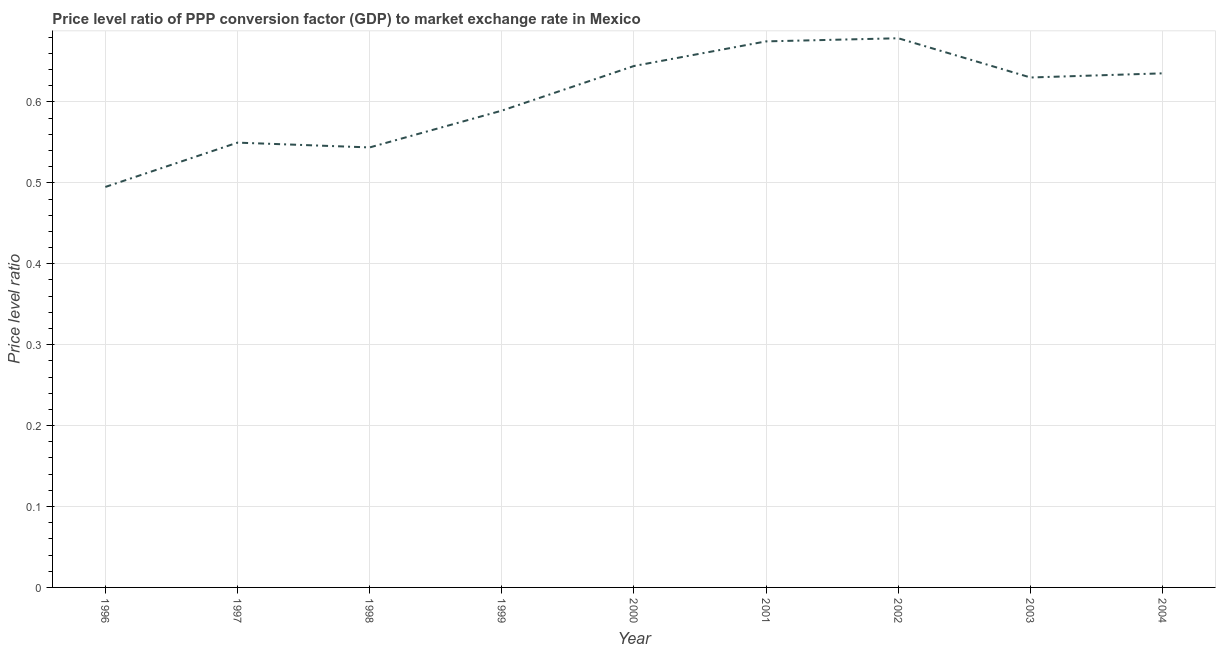What is the price level ratio in 1999?
Provide a succinct answer. 0.59. Across all years, what is the maximum price level ratio?
Offer a terse response. 0.68. Across all years, what is the minimum price level ratio?
Ensure brevity in your answer.  0.49. In which year was the price level ratio maximum?
Your answer should be very brief. 2002. In which year was the price level ratio minimum?
Keep it short and to the point. 1996. What is the sum of the price level ratio?
Your answer should be compact. 5.44. What is the difference between the price level ratio in 1998 and 2003?
Provide a short and direct response. -0.09. What is the average price level ratio per year?
Keep it short and to the point. 0.6. What is the median price level ratio?
Offer a terse response. 0.63. Do a majority of the years between 2001 and 2002 (inclusive) have price level ratio greater than 0.46 ?
Offer a very short reply. Yes. What is the ratio of the price level ratio in 2001 to that in 2003?
Your response must be concise. 1.07. What is the difference between the highest and the second highest price level ratio?
Provide a succinct answer. 0. What is the difference between the highest and the lowest price level ratio?
Your answer should be very brief. 0.18. How many lines are there?
Your response must be concise. 1. What is the difference between two consecutive major ticks on the Y-axis?
Offer a terse response. 0.1. Are the values on the major ticks of Y-axis written in scientific E-notation?
Ensure brevity in your answer.  No. Does the graph contain any zero values?
Make the answer very short. No. What is the title of the graph?
Provide a short and direct response. Price level ratio of PPP conversion factor (GDP) to market exchange rate in Mexico. What is the label or title of the X-axis?
Provide a succinct answer. Year. What is the label or title of the Y-axis?
Keep it short and to the point. Price level ratio. What is the Price level ratio in 1996?
Offer a terse response. 0.49. What is the Price level ratio in 1997?
Make the answer very short. 0.55. What is the Price level ratio in 1998?
Keep it short and to the point. 0.54. What is the Price level ratio of 1999?
Your response must be concise. 0.59. What is the Price level ratio of 2000?
Your answer should be very brief. 0.64. What is the Price level ratio of 2001?
Your response must be concise. 0.67. What is the Price level ratio in 2002?
Your answer should be very brief. 0.68. What is the Price level ratio in 2003?
Your answer should be compact. 0.63. What is the Price level ratio in 2004?
Your answer should be compact. 0.64. What is the difference between the Price level ratio in 1996 and 1997?
Your answer should be compact. -0.05. What is the difference between the Price level ratio in 1996 and 1998?
Make the answer very short. -0.05. What is the difference between the Price level ratio in 1996 and 1999?
Make the answer very short. -0.09. What is the difference between the Price level ratio in 1996 and 2000?
Give a very brief answer. -0.15. What is the difference between the Price level ratio in 1996 and 2001?
Ensure brevity in your answer.  -0.18. What is the difference between the Price level ratio in 1996 and 2002?
Keep it short and to the point. -0.18. What is the difference between the Price level ratio in 1996 and 2003?
Your answer should be very brief. -0.14. What is the difference between the Price level ratio in 1996 and 2004?
Make the answer very short. -0.14. What is the difference between the Price level ratio in 1997 and 1998?
Your response must be concise. 0.01. What is the difference between the Price level ratio in 1997 and 1999?
Give a very brief answer. -0.04. What is the difference between the Price level ratio in 1997 and 2000?
Your response must be concise. -0.09. What is the difference between the Price level ratio in 1997 and 2001?
Keep it short and to the point. -0.13. What is the difference between the Price level ratio in 1997 and 2002?
Offer a very short reply. -0.13. What is the difference between the Price level ratio in 1997 and 2003?
Provide a succinct answer. -0.08. What is the difference between the Price level ratio in 1997 and 2004?
Keep it short and to the point. -0.09. What is the difference between the Price level ratio in 1998 and 1999?
Your answer should be very brief. -0.05. What is the difference between the Price level ratio in 1998 and 2000?
Provide a short and direct response. -0.1. What is the difference between the Price level ratio in 1998 and 2001?
Your answer should be very brief. -0.13. What is the difference between the Price level ratio in 1998 and 2002?
Ensure brevity in your answer.  -0.13. What is the difference between the Price level ratio in 1998 and 2003?
Keep it short and to the point. -0.09. What is the difference between the Price level ratio in 1998 and 2004?
Offer a very short reply. -0.09. What is the difference between the Price level ratio in 1999 and 2000?
Provide a succinct answer. -0.06. What is the difference between the Price level ratio in 1999 and 2001?
Make the answer very short. -0.09. What is the difference between the Price level ratio in 1999 and 2002?
Give a very brief answer. -0.09. What is the difference between the Price level ratio in 1999 and 2003?
Provide a short and direct response. -0.04. What is the difference between the Price level ratio in 1999 and 2004?
Give a very brief answer. -0.05. What is the difference between the Price level ratio in 2000 and 2001?
Provide a succinct answer. -0.03. What is the difference between the Price level ratio in 2000 and 2002?
Ensure brevity in your answer.  -0.03. What is the difference between the Price level ratio in 2000 and 2003?
Give a very brief answer. 0.01. What is the difference between the Price level ratio in 2000 and 2004?
Give a very brief answer. 0.01. What is the difference between the Price level ratio in 2001 and 2002?
Your answer should be very brief. -0. What is the difference between the Price level ratio in 2001 and 2003?
Keep it short and to the point. 0.04. What is the difference between the Price level ratio in 2001 and 2004?
Your response must be concise. 0.04. What is the difference between the Price level ratio in 2002 and 2003?
Give a very brief answer. 0.05. What is the difference between the Price level ratio in 2002 and 2004?
Keep it short and to the point. 0.04. What is the difference between the Price level ratio in 2003 and 2004?
Your answer should be very brief. -0.01. What is the ratio of the Price level ratio in 1996 to that in 1998?
Make the answer very short. 0.91. What is the ratio of the Price level ratio in 1996 to that in 1999?
Provide a short and direct response. 0.84. What is the ratio of the Price level ratio in 1996 to that in 2000?
Give a very brief answer. 0.77. What is the ratio of the Price level ratio in 1996 to that in 2001?
Your answer should be compact. 0.73. What is the ratio of the Price level ratio in 1996 to that in 2002?
Ensure brevity in your answer.  0.73. What is the ratio of the Price level ratio in 1996 to that in 2003?
Your answer should be compact. 0.79. What is the ratio of the Price level ratio in 1996 to that in 2004?
Provide a succinct answer. 0.78. What is the ratio of the Price level ratio in 1997 to that in 1998?
Offer a terse response. 1.01. What is the ratio of the Price level ratio in 1997 to that in 1999?
Offer a terse response. 0.93. What is the ratio of the Price level ratio in 1997 to that in 2000?
Provide a short and direct response. 0.85. What is the ratio of the Price level ratio in 1997 to that in 2001?
Offer a terse response. 0.81. What is the ratio of the Price level ratio in 1997 to that in 2002?
Offer a very short reply. 0.81. What is the ratio of the Price level ratio in 1997 to that in 2003?
Make the answer very short. 0.87. What is the ratio of the Price level ratio in 1997 to that in 2004?
Give a very brief answer. 0.86. What is the ratio of the Price level ratio in 1998 to that in 1999?
Your answer should be very brief. 0.92. What is the ratio of the Price level ratio in 1998 to that in 2000?
Your response must be concise. 0.84. What is the ratio of the Price level ratio in 1998 to that in 2001?
Provide a succinct answer. 0.81. What is the ratio of the Price level ratio in 1998 to that in 2002?
Make the answer very short. 0.8. What is the ratio of the Price level ratio in 1998 to that in 2003?
Your response must be concise. 0.86. What is the ratio of the Price level ratio in 1998 to that in 2004?
Ensure brevity in your answer.  0.86. What is the ratio of the Price level ratio in 1999 to that in 2000?
Give a very brief answer. 0.91. What is the ratio of the Price level ratio in 1999 to that in 2001?
Your response must be concise. 0.87. What is the ratio of the Price level ratio in 1999 to that in 2002?
Your response must be concise. 0.87. What is the ratio of the Price level ratio in 1999 to that in 2003?
Provide a succinct answer. 0.94. What is the ratio of the Price level ratio in 1999 to that in 2004?
Give a very brief answer. 0.93. What is the ratio of the Price level ratio in 2000 to that in 2001?
Provide a short and direct response. 0.95. What is the ratio of the Price level ratio in 2000 to that in 2003?
Keep it short and to the point. 1.02. What is the ratio of the Price level ratio in 2001 to that in 2003?
Keep it short and to the point. 1.07. What is the ratio of the Price level ratio in 2001 to that in 2004?
Your answer should be very brief. 1.06. What is the ratio of the Price level ratio in 2002 to that in 2003?
Your answer should be very brief. 1.08. What is the ratio of the Price level ratio in 2002 to that in 2004?
Provide a short and direct response. 1.07. What is the ratio of the Price level ratio in 2003 to that in 2004?
Give a very brief answer. 0.99. 